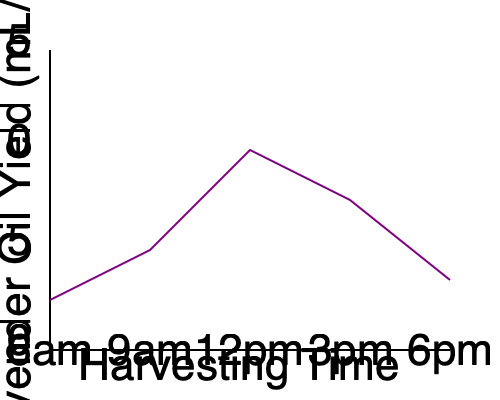Based on the line graph showing lavender oil yield at different harvesting times, what is the optimal time to harvest lavender for maximum oil yield, and how might this information impact your boutique's product sourcing and pricing strategy? To answer this question, let's analyze the graph step-by-step:

1. The x-axis represents harvesting times from 6am to 6pm.
2. The y-axis represents lavender oil yield in mL/kg.
3. The purple line shows the relationship between harvesting time and oil yield.

4. Examining the line:
   - It starts relatively low at 6am
   - Rises slightly at 9am
   - Peaks at 12pm (noon)
   - Decreases at 3pm
   - Further decreases at 6pm

5. The highest point on the graph corresponds to 12pm, indicating this is the optimal time for harvesting to maximize oil yield.

6. Impact on boutique strategy:
   a) Sourcing: Partner with lavender farmers who harvest at noon for highest quality oil.
   b) Pricing: Products made with optimally harvested lavender could be premium-priced.
   c) Marketing: Educate customers about the importance of harvest time on oil quality.
   d) Product development: Focus on products that showcase the high-quality oil.
   e) Inventory management: Plan for potential yield fluctuations based on harvest times.

7. The optimal harvesting time (12pm) likely coincides with the highest concentration of essential oils in the lavender plants due to environmental factors such as temperature and sunlight exposure.
Answer: 12pm; optimize sourcing, increase prices for premium products, educate customers on quality. 